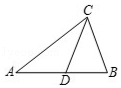Given the triangle ABC where CD is a median, could you explain why the properties of a median are crucial for solving problems related to triangle's measurements? Certainly! In triangle ABC, the median CD plays a key role because it divides the opposite side AB into two equal segments, AD and BD. This property is essential in geometric proofs and calculations as it provides a symmetry that simplifies the analysis of the triangle's properties. Understanding how medians affect triangle geometry aids in solving various problems by utilizing their bisecting and balancing properties. 